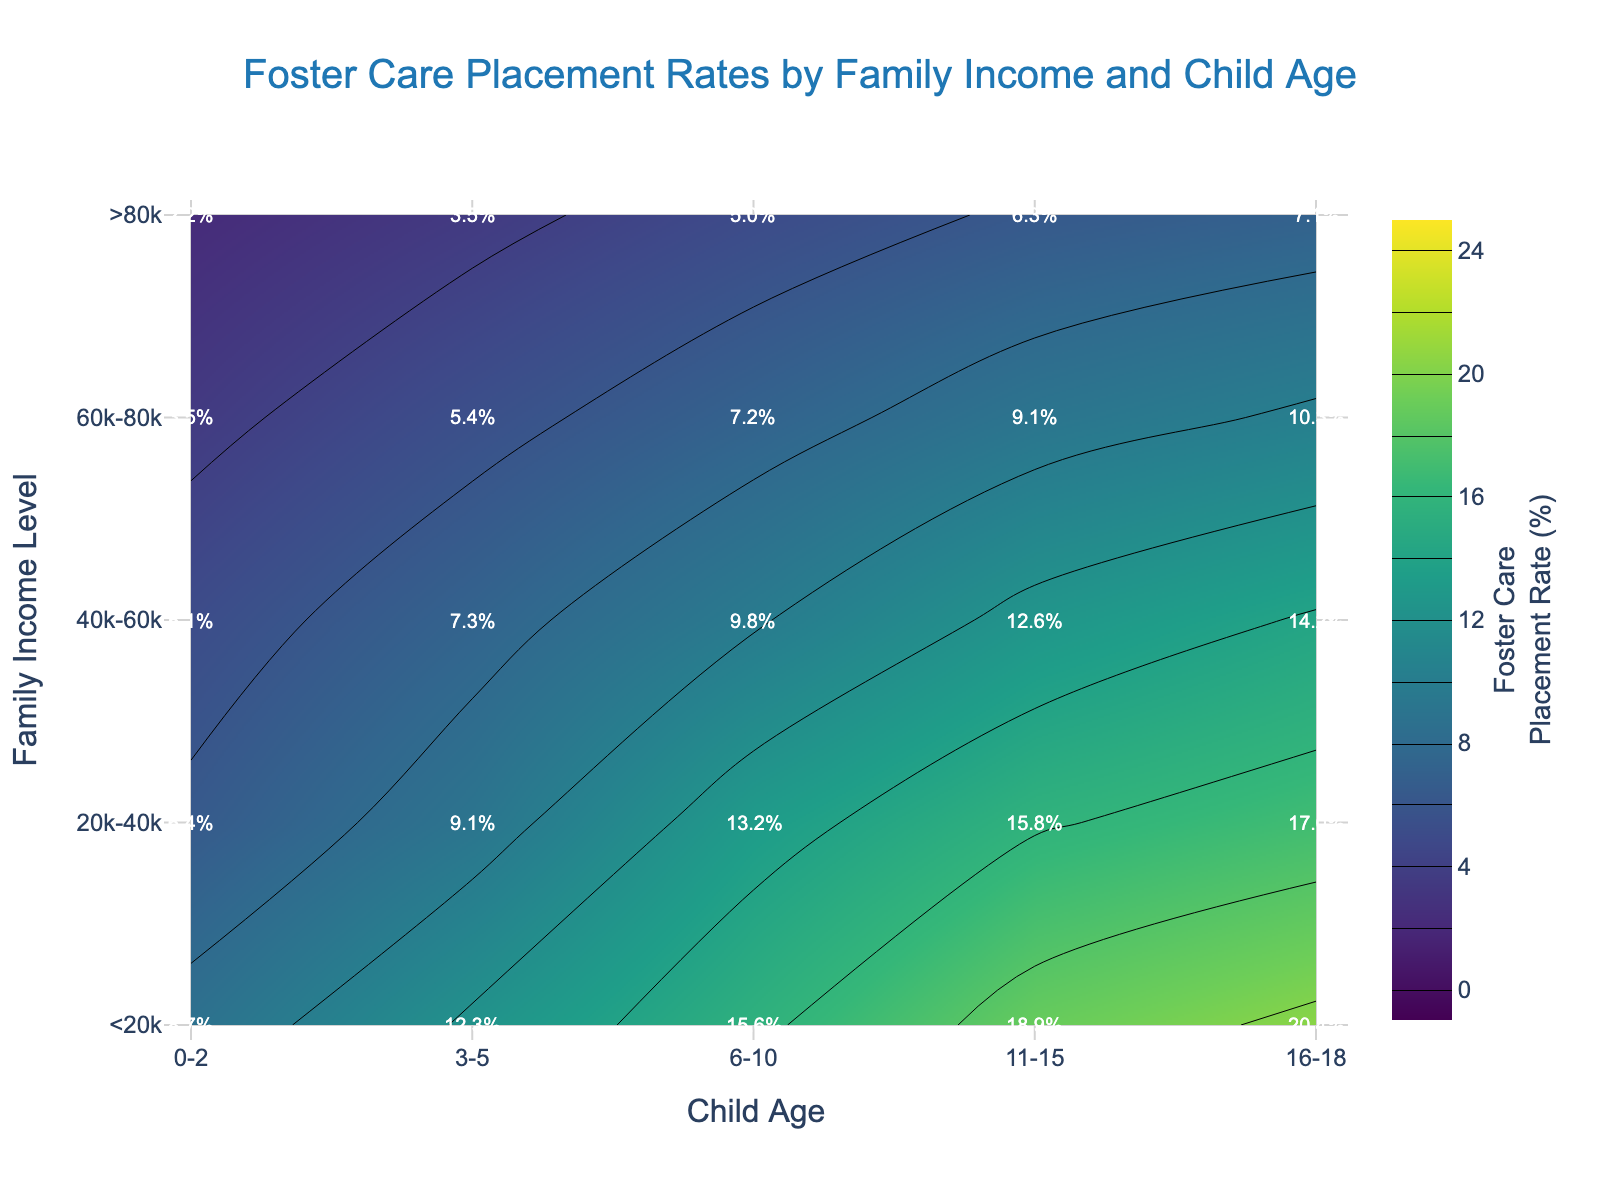What is the title of the figure? The title is displayed at the top of the figure. It reads "Foster Care Placement Rates by Family Income and Child Age".
Answer: Foster Care Placement Rates by Family Income and Child Age What are the x-axis and y-axis labels in this plot? The x-axis label appears at the bottom and reads "Child Age". The y-axis label appears on the left side and reads "Family Income Level".
Answer: Child Age; Family Income Level What is the foster care placement rate for children aged 6-10 from families earning 20k-40k? Locate the intersection of "20k-40k" on the y-axis and "6-10" on the x-axis. The contour label at this intersection reads "13.2%".
Answer: 13.2% Which income level has the highest foster care placement rate for children aged 0-2? Find the rates for "0-2" on the x-axis across all income levels on the y-axis: rates are 8.7%, 6.4%, 5.1%, 3.5%, and 2.2%. The highest rate is 8.7% for "<20k".
Answer: <20k How does the foster care placement rate change as age increases for families with incomes less than 20k? Observe the contour labels vertically along the income level "<20k": the rates are 8.7%, 12.3%, 15.6%, 18.9%, 20.4%. The rate increases with age.
Answer: Increases What is the average foster care placement rate for children aged 11-15 across all income levels? Add the rates for "11-15" across all income levels: 18.9%, 15.8%, 12.6%, 9.1%, 6.3%. Calculate the average: (18.9 + 15.8 + 12.6 + 9.1 + 6.3) / 5 ≈ 12.54%.
Answer: 12.54% Between which ages does the foster care placement rate for families with incomes of 40k-60k increase the most? Compare the rate differences for "40k-60k" across age ranges: 5.1%, 7.3%, 9.8%, 12.6%, 14.2%. The largest increase is from 5.1% to 7.3% between ages 0-2 and 3-5 (a 2.2% increase).
Answer: 0-2 and 3-5 Does any income level show a decreasing trend in foster care placement rate as child age increases? Review contour labels for each income level vertically to determine trend with age increase. All income levels (<20k, 20k-40k, 40k-60k, etc.) show increasing or steady rates; none show a decrease.
Answer: No Which combination of age and income level has the lowest foster care placement rate in the figure? Determine the lowest rate from all combinations shown in the figure. The minimum rate is 2.2%, which occurs at ">80k" income level and "0-2" age range.
Answer: >80k and 0-2 